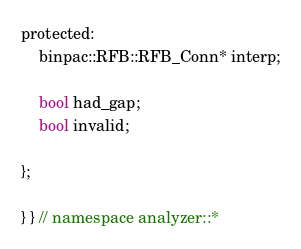Convert code to text. <code><loc_0><loc_0><loc_500><loc_500><_C_>protected:
	binpac::RFB::RFB_Conn* interp;

	bool had_gap;
	bool invalid;

};

} } // namespace analyzer::*
</code> 